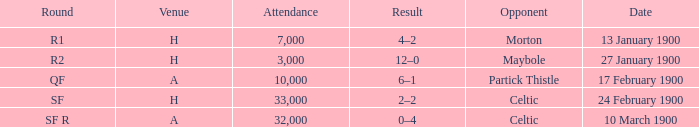What round did the celtic played away on 24 february 1900? SF. 